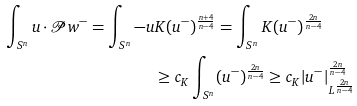<formula> <loc_0><loc_0><loc_500><loc_500>\int _ { S ^ { n } } u \cdot \mathcal { P } w ^ { - } = \int _ { S ^ { n } } - u & K ( u ^ { - } ) ^ { \frac { n + 4 } { n - 4 } } = \int _ { S ^ { n } } K ( u ^ { - } ) ^ { \frac { 2 n } { n - 4 } } \\ & \geq c _ { K } \int _ { S ^ { n } } ( u ^ { - } ) ^ { \frac { 2 n } { n - 4 } } \geq c _ { K } | u ^ { - } | _ { L ^ { \frac { 2 n } { n - 4 } } } ^ { \frac { 2 n } { n - 4 } }</formula> 